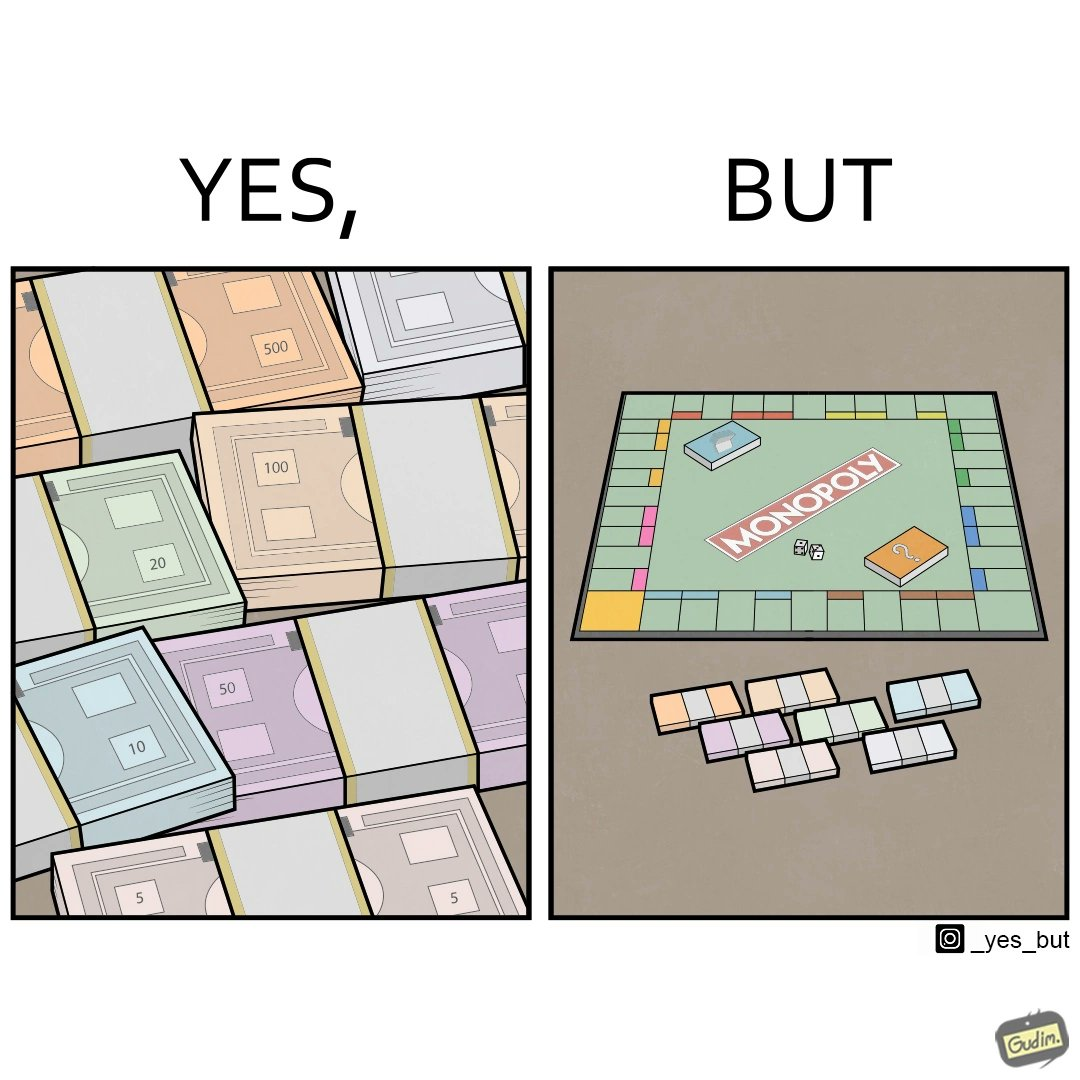Explain why this image is satirical. The image is ironic, because there are many different color currency notes' bundles but they are just as a currency in the game of monopoly and they have no real value 